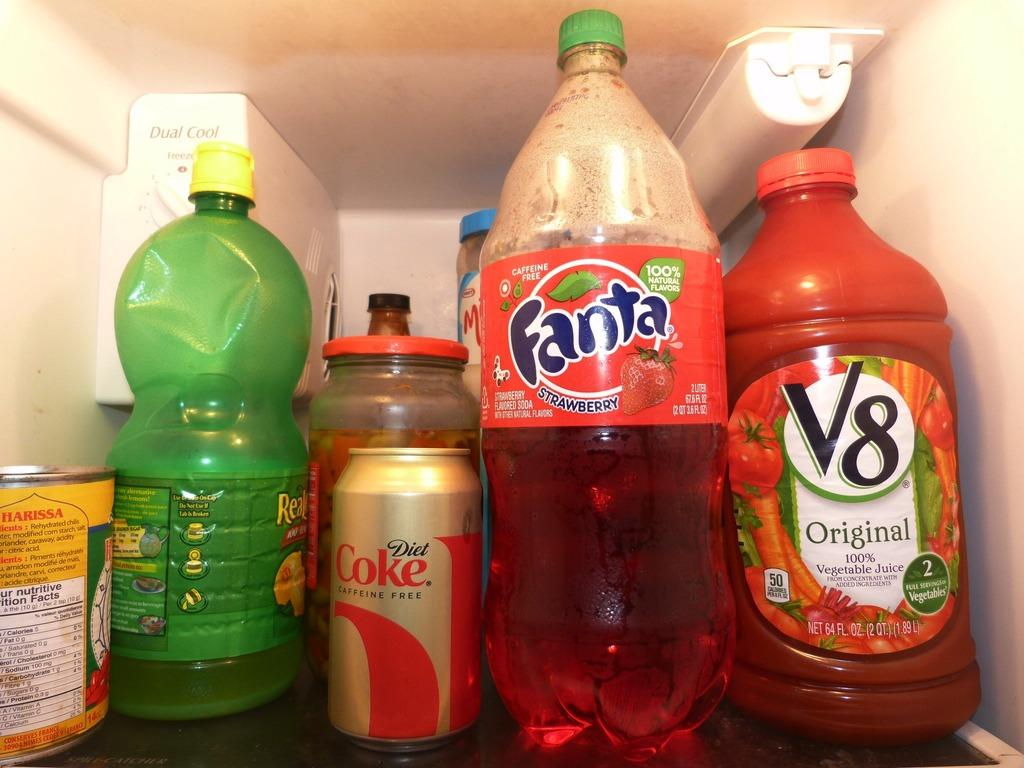<image>
Render a clear and concise summary of the photo. bottles of drinks inside a fridge include Fanta and V8 